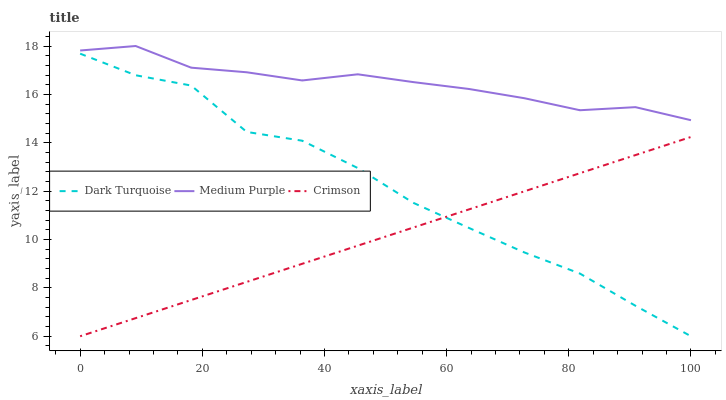Does Crimson have the minimum area under the curve?
Answer yes or no. Yes. Does Medium Purple have the maximum area under the curve?
Answer yes or no. Yes. Does Dark Turquoise have the minimum area under the curve?
Answer yes or no. No. Does Dark Turquoise have the maximum area under the curve?
Answer yes or no. No. Is Crimson the smoothest?
Answer yes or no. Yes. Is Dark Turquoise the roughest?
Answer yes or no. Yes. Is Dark Turquoise the smoothest?
Answer yes or no. No. Is Crimson the roughest?
Answer yes or no. No. Does Dark Turquoise have the highest value?
Answer yes or no. No. Is Dark Turquoise less than Medium Purple?
Answer yes or no. Yes. Is Medium Purple greater than Crimson?
Answer yes or no. Yes. Does Dark Turquoise intersect Medium Purple?
Answer yes or no. No. 